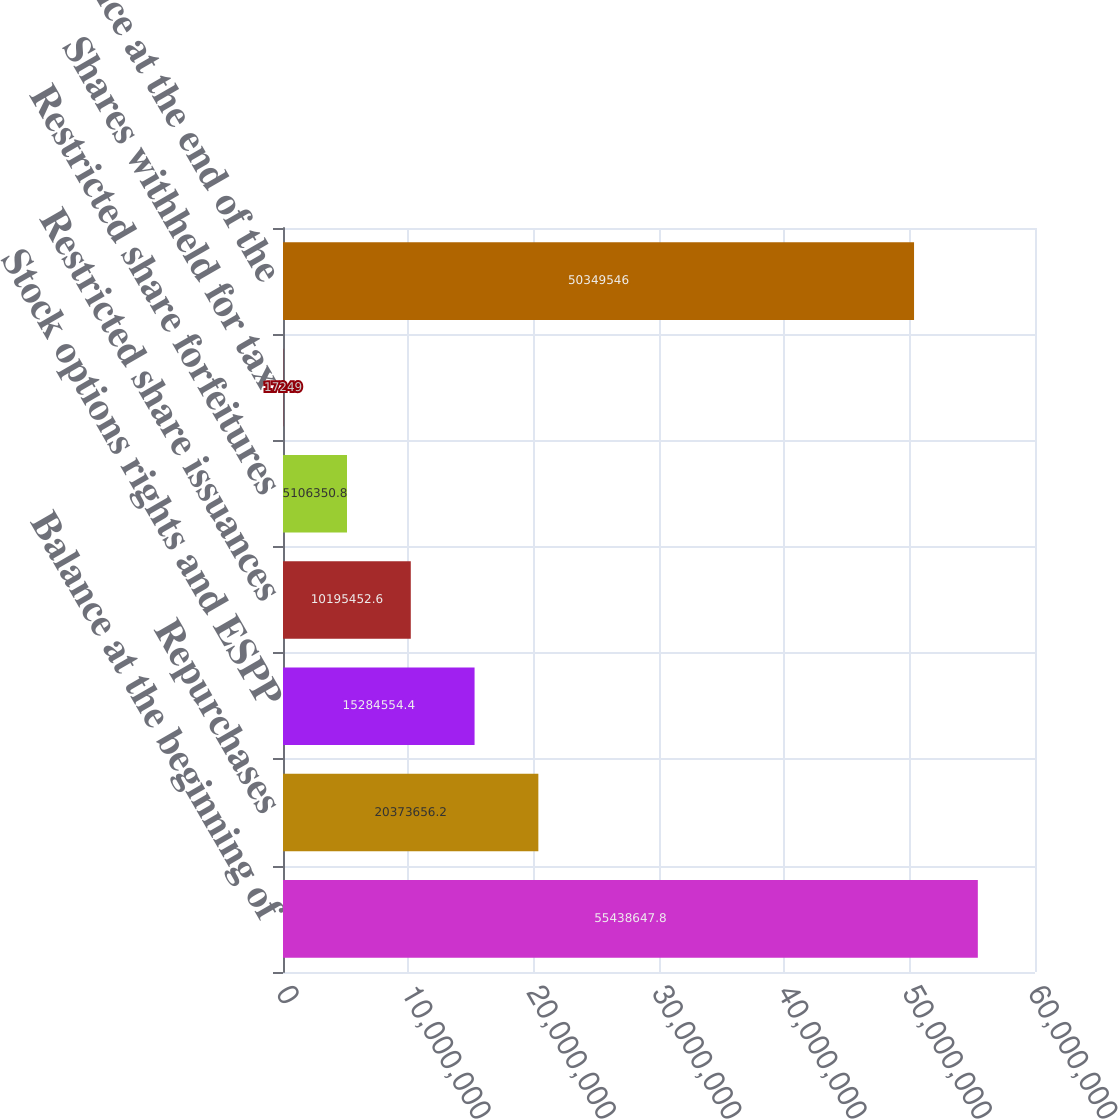<chart> <loc_0><loc_0><loc_500><loc_500><bar_chart><fcel>Balance at the beginning of<fcel>Repurchases<fcel>Stock options rights and ESPP<fcel>Restricted share issuances<fcel>Restricted share forfeitures<fcel>Shares withheld for tax<fcel>Balance at the end of the<nl><fcel>5.54386e+07<fcel>2.03737e+07<fcel>1.52846e+07<fcel>1.01955e+07<fcel>5.10635e+06<fcel>17249<fcel>5.03495e+07<nl></chart> 